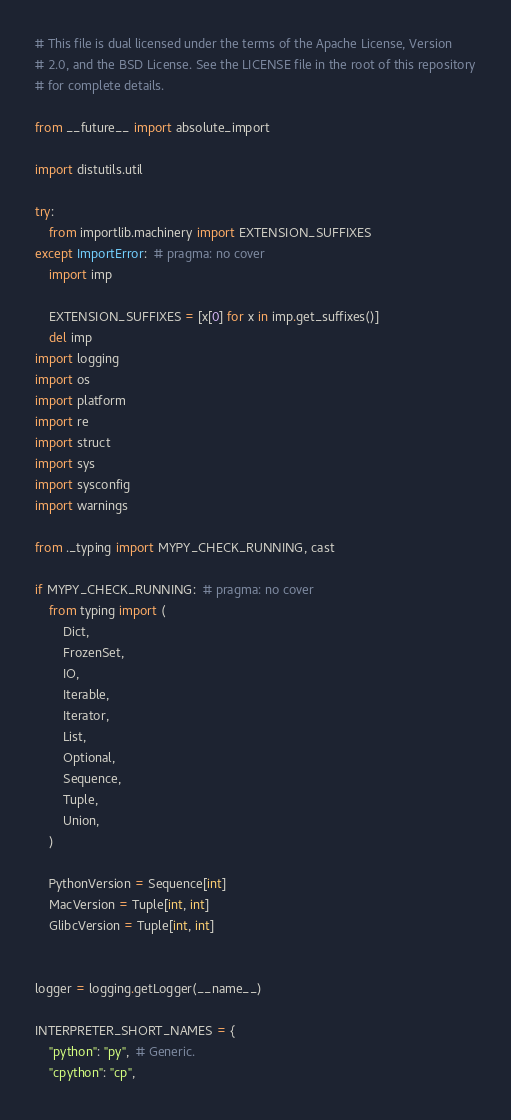<code> <loc_0><loc_0><loc_500><loc_500><_Python_># This file is dual licensed under the terms of the Apache License, Version
# 2.0, and the BSD License. See the LICENSE file in the root of this repository
# for complete details.

from __future__ import absolute_import

import distutils.util

try:
    from importlib.machinery import EXTENSION_SUFFIXES
except ImportError:  # pragma: no cover
    import imp

    EXTENSION_SUFFIXES = [x[0] for x in imp.get_suffixes()]
    del imp
import logging
import os
import platform
import re
import struct
import sys
import sysconfig
import warnings

from ._typing import MYPY_CHECK_RUNNING, cast

if MYPY_CHECK_RUNNING:  # pragma: no cover
    from typing import (
        Dict,
        FrozenSet,
        IO,
        Iterable,
        Iterator,
        List,
        Optional,
        Sequence,
        Tuple,
        Union,
    )

    PythonVersion = Sequence[int]
    MacVersion = Tuple[int, int]
    GlibcVersion = Tuple[int, int]


logger = logging.getLogger(__name__)

INTERPRETER_SHORT_NAMES = {
    "python": "py",  # Generic.
    "cpython": "cp",</code> 